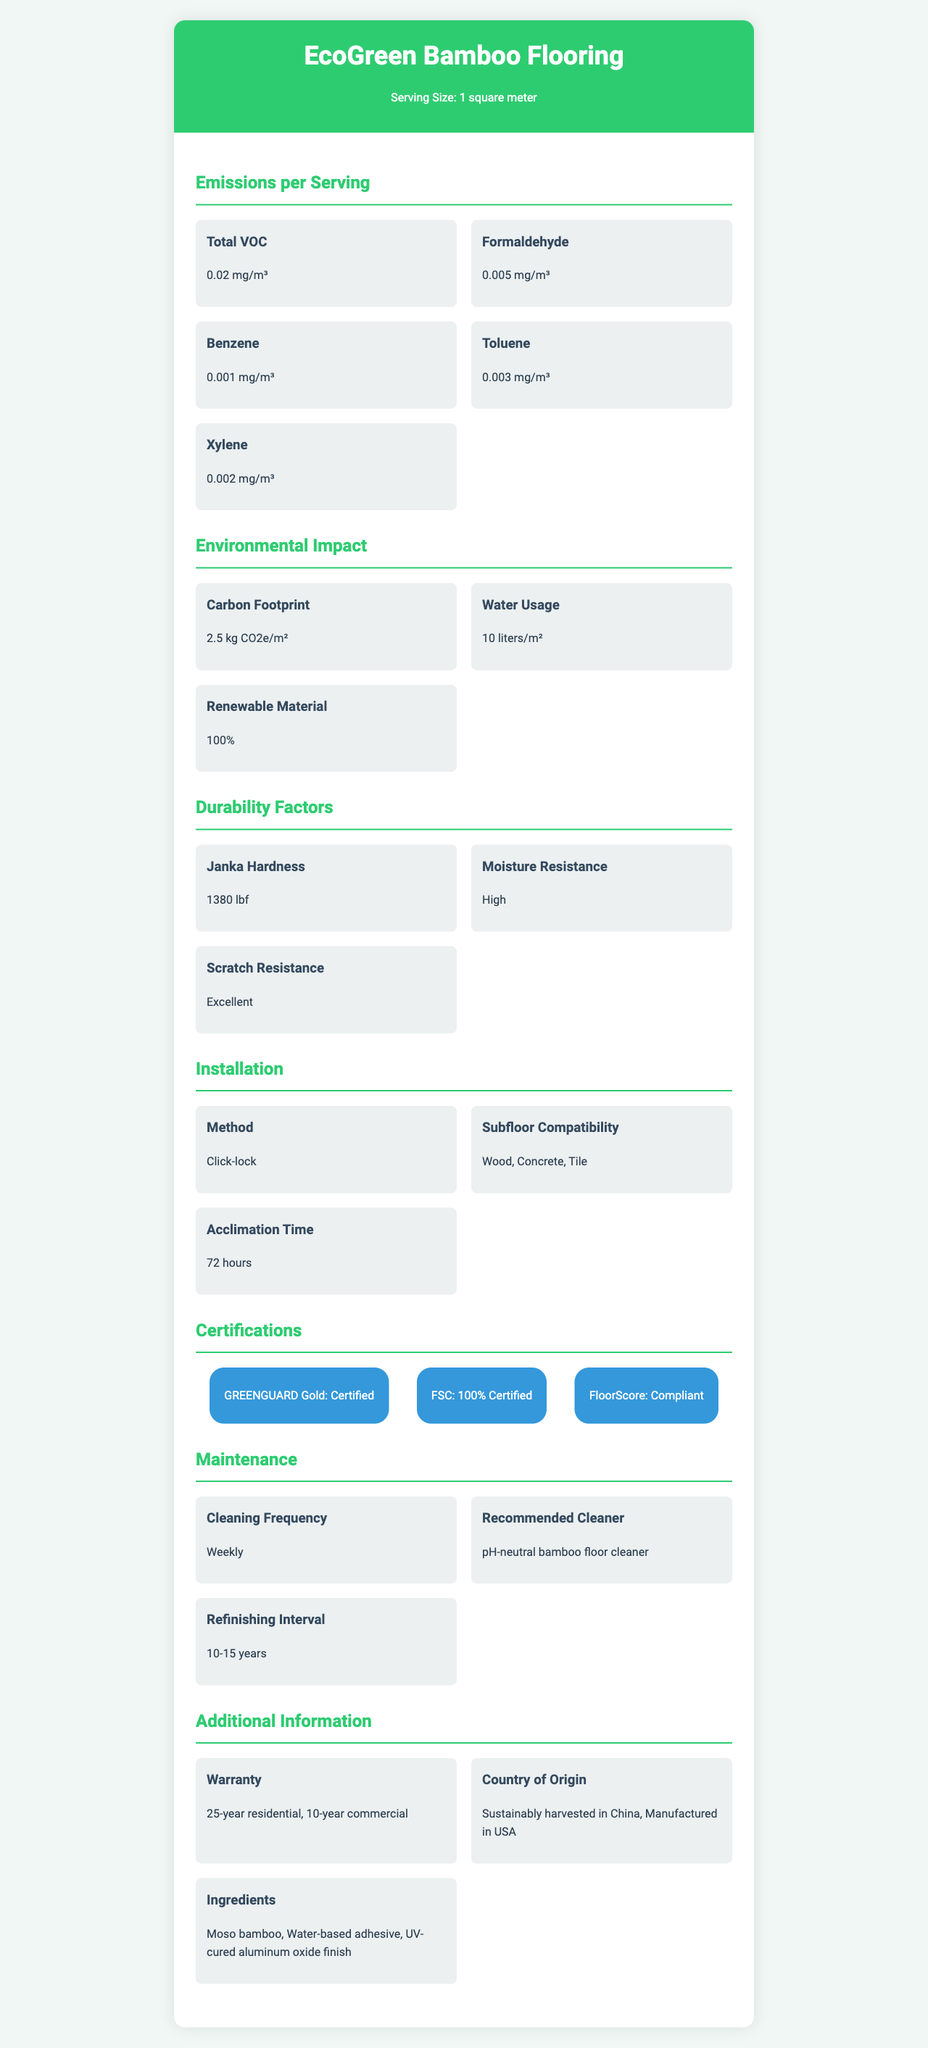What is the serving size for EcoGreen Bamboo Flooring? The document specifies the serving size as "1 square meter" under the "Product Name" section.
Answer: 1 square meter How much Total VOC is emitted per serving? The document indicates that "Total VOC" emissions per serving are "0.02 mg/m³".
Answer: 0.02 mg/m³ What is the carbon footprint of EcoGreen Bamboo Flooring? The "Environmental Impact" section states that the carbon footprint is "2.5 kg CO2e/m²".
Answer: 2.5 kg CO2e/m² What is the Janka Hardness of the product? The "Durability Factors" section lists the Janka Hardness as "1380 lbf".
Answer: 1380 lbf Describe the installation method of EcoGreen Bamboo Flooring. The "Installation" section describes the method as "Click-lock".
Answer: Click-lock Which of the following VOCs has the lowest emission value?
1. Formaldehyde
2. Benzene
3. Toluene
4. Xylene The "Emissions per Serving" section indicates that Benzene has the lowest emission value at "0.001 mg/m³".
Answer: 2. Benzene Which certification(s) does EcoGreen Bamboo Flooring have?
A. GREENGUARD Gold
B. FSC
C. FloorScore
D. All of the above The "Certifications" section states that the product is "GREENGUARD Gold", "FSC", and "FloorScore" certified.
Answer: D. All of the above Does EcoGreen Bamboo Flooring require specialized cleaners? The "Maintenance" section recommends using a "pH-neutral bamboo floor cleaner".
Answer: Yes Summarize the main idea of the document. The document gives a detailed overview of EcoGreen Bamboo Flooring, emphasizing its eco-friendly features and high quality by listing its specifications, emissions data, and certifications.
Answer: The document provides comprehensive information about EcoGreen Bamboo Flooring, highlighting its low VOC emissions, environmental impact, durability, and certifications. It includes details on installation methods, maintenance recommendations, and warranty information. How many liters of water are used per square meter of this flooring? The "Environmental Impact" section lists water usage as "10 liters/m²".
Answer: 10 liters/m² What is the warranty period for residential usage? The "Warranty" section mentions that the product has a "25-year residential" warranty.
Answer: 25 years What kind of subfloors is EcoGreen Bamboo Flooring compatible with? The "Installation" section lists subfloor compatibility as "Wood, Concrete, Tile".
Answer: Wood, Concrete, Tile What adhesive is used in EcoGreen Bamboo Flooring? The "Ingredients" section mentions that a "Water-based adhesive" is used.
Answer: Water-based adhesive Can the product be used in commercial settings?
A. Yes, up to 5 years
B. Yes, up to 10 years
C. Yes, up to 15 years
D. No, only residential The "Warranty" section specifies a "10-year commercial" warranty, indicating its suitability for commercial use.
Answer: B. Yes, up to 10 years What is the acclimation time required before installation? The "Installation" section lists the acclimation time as "72 hours".
Answer: 72 hours Can the exact manufacturing location in the USA be determined from the document? The document only indicates that the product is "Manufactured in USA" but does not provide a specific location.
Answer: Cannot be determined 